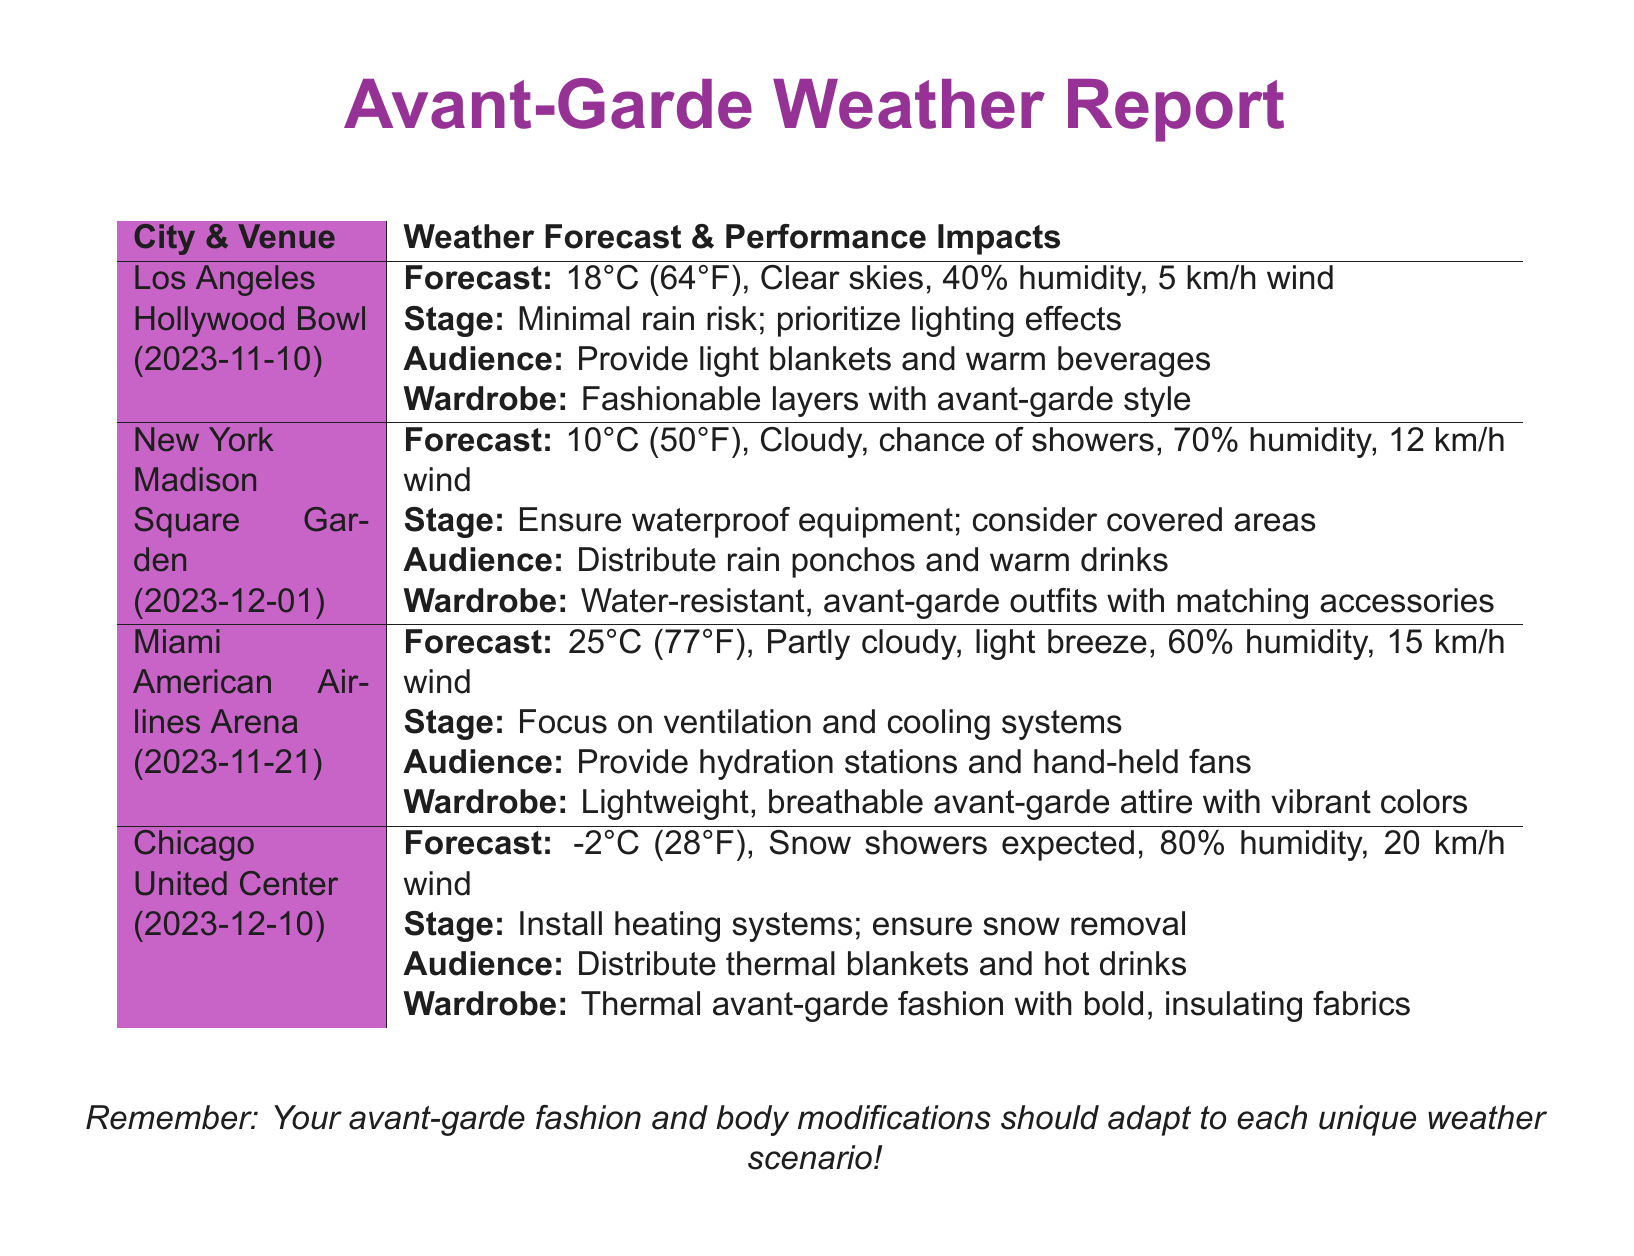What is the temperature forecast for Los Angeles? The temperature forecast is listed in the document as 18°C (64°F).
Answer: 18°C (64°F) What is the humidity percentage during the performance in Chicago? The humidity percentage for the Chicago performance is provided in the document, which is 80%.
Answer: 80% What audience comfort measure is recommended for the Miami performance? The document suggests providing hydration stations and hand-held fans to the audience in Miami.
Answer: Hydration stations and hand-held fans What wardrobe style is suggested for the event in New York? The document states that water-resistant, avant-garde outfits with matching accessories are recommended for New York.
Answer: Water-resistant, avant-garde outfits What is the wind speed forecast for the Los Angeles performance? The wind speed forecast is mentioned in the document as 5 km/h.
Answer: 5 km/h What stage setup measure is advised for the New York performance? The document advises ensuring waterproof equipment and considering covered areas for the New York stage setup.
Answer: Waterproof equipment and covered areas Which city will experience snow showers according to the forecast? The forecast indicates that Chicago is expected to experience snow showers.
Answer: Chicago What is the style of attire recommended for the Chicago performance? The document recommends thermal avant-garde fashion with bold, insulating fabrics for the Chicago performance.
Answer: Thermal avant-garde fashion What unique adaptations does the report suggest for wardrobe based on performance conditions? The report suggests that avant-garde fashion and body modifications should adapt to each unique weather scenario.
Answer: Adapt to each unique weather scenario 